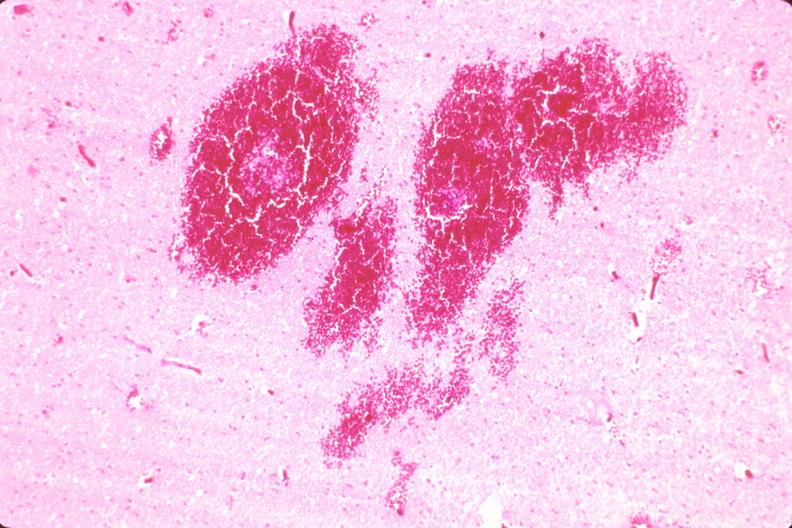what is present?
Answer the question using a single word or phrase. Nervous 